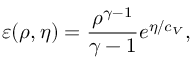Convert formula to latex. <formula><loc_0><loc_0><loc_500><loc_500>\varepsilon ( \rho , \eta ) = \frac { \rho ^ { \gamma - 1 } } { \gamma - 1 } e ^ { \eta / c _ { V } } ,</formula> 